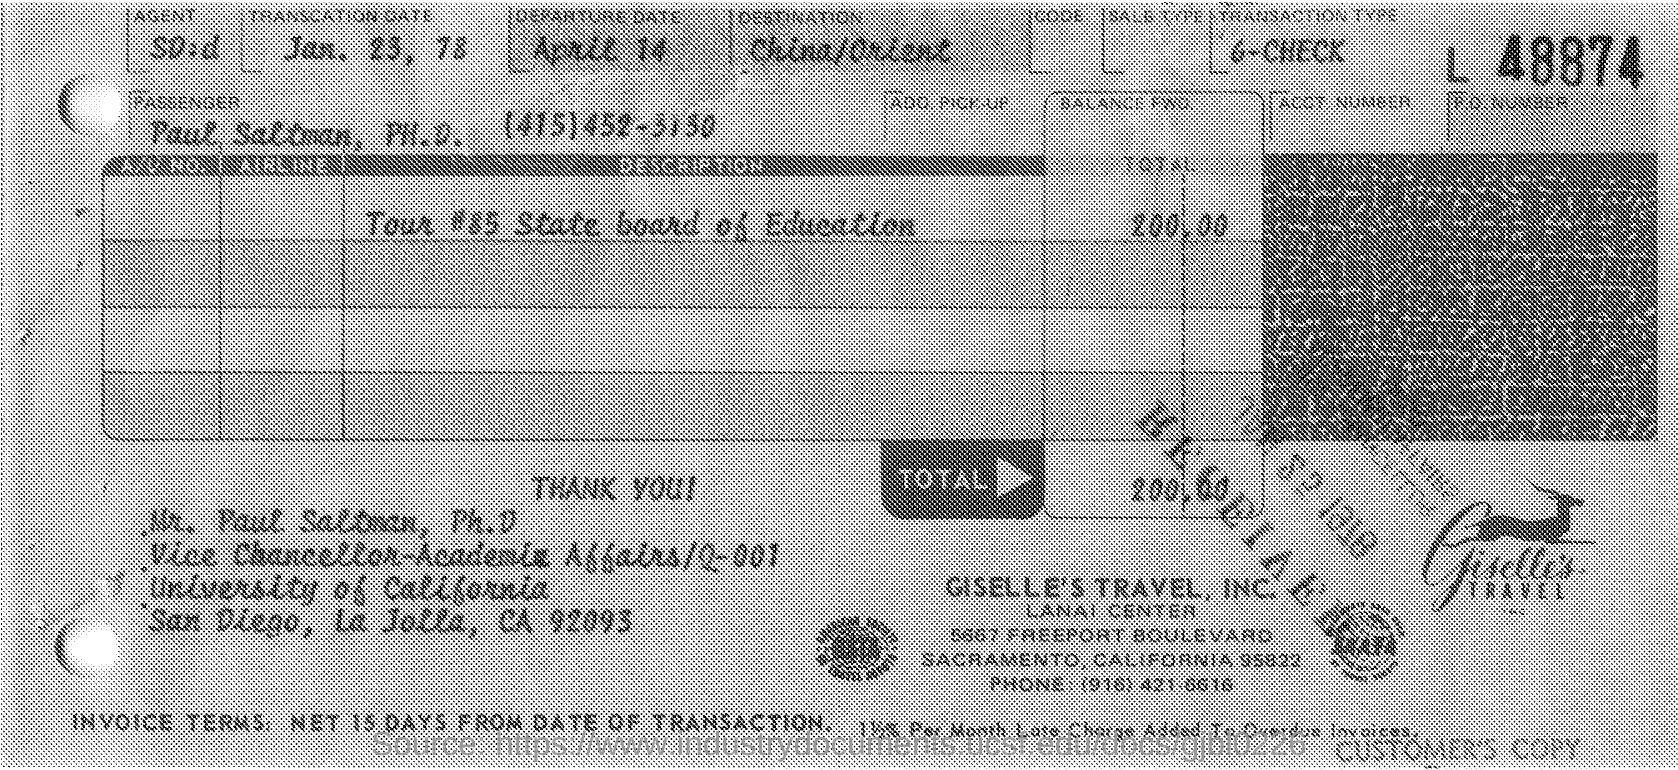When was the TRANSACTION done?
Your answer should be very brief. Jan 23, 78. What's the TRANSACTION TYPE?
Give a very brief answer. 6-CHECK. Where's the DESTINATION?
Ensure brevity in your answer.  China/Orient. What is the travel expenses?
Make the answer very short. 200.00. Whats the name of travel company?
Provide a short and direct response. GISELLE'S TRAVEL, INC. 